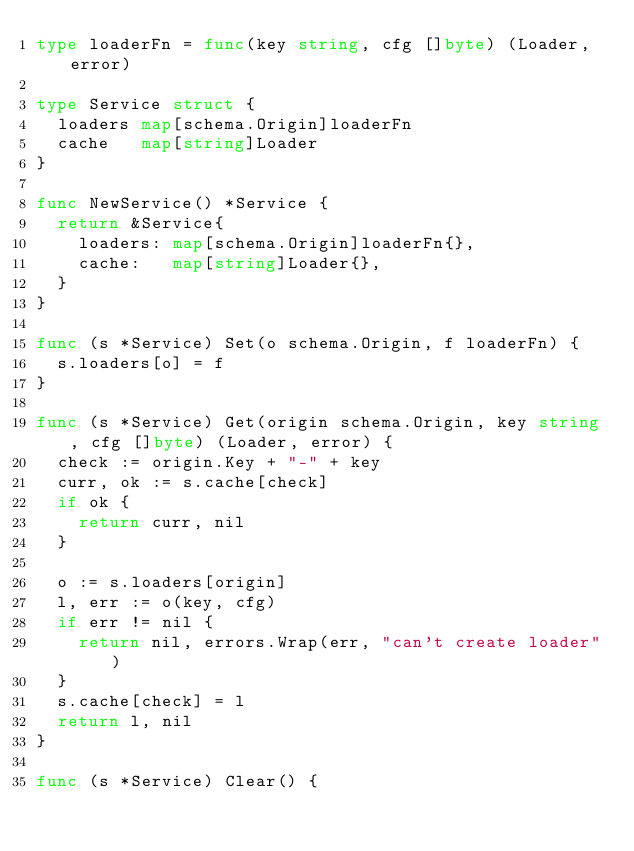<code> <loc_0><loc_0><loc_500><loc_500><_Go_>type loaderFn = func(key string, cfg []byte) (Loader, error)

type Service struct {
	loaders map[schema.Origin]loaderFn
	cache   map[string]Loader
}

func NewService() *Service {
	return &Service{
		loaders: map[schema.Origin]loaderFn{},
		cache:   map[string]Loader{},
	}
}

func (s *Service) Set(o schema.Origin, f loaderFn) {
	s.loaders[o] = f
}

func (s *Service) Get(origin schema.Origin, key string, cfg []byte) (Loader, error) {
	check := origin.Key + "-" + key
	curr, ok := s.cache[check]
	if ok {
		return curr, nil
	}

	o := s.loaders[origin]
	l, err := o(key, cfg)
	if err != nil {
		return nil, errors.Wrap(err, "can't create loader")
	}
	s.cache[check] = l
	return l, nil
}

func (s *Service) Clear() {</code> 